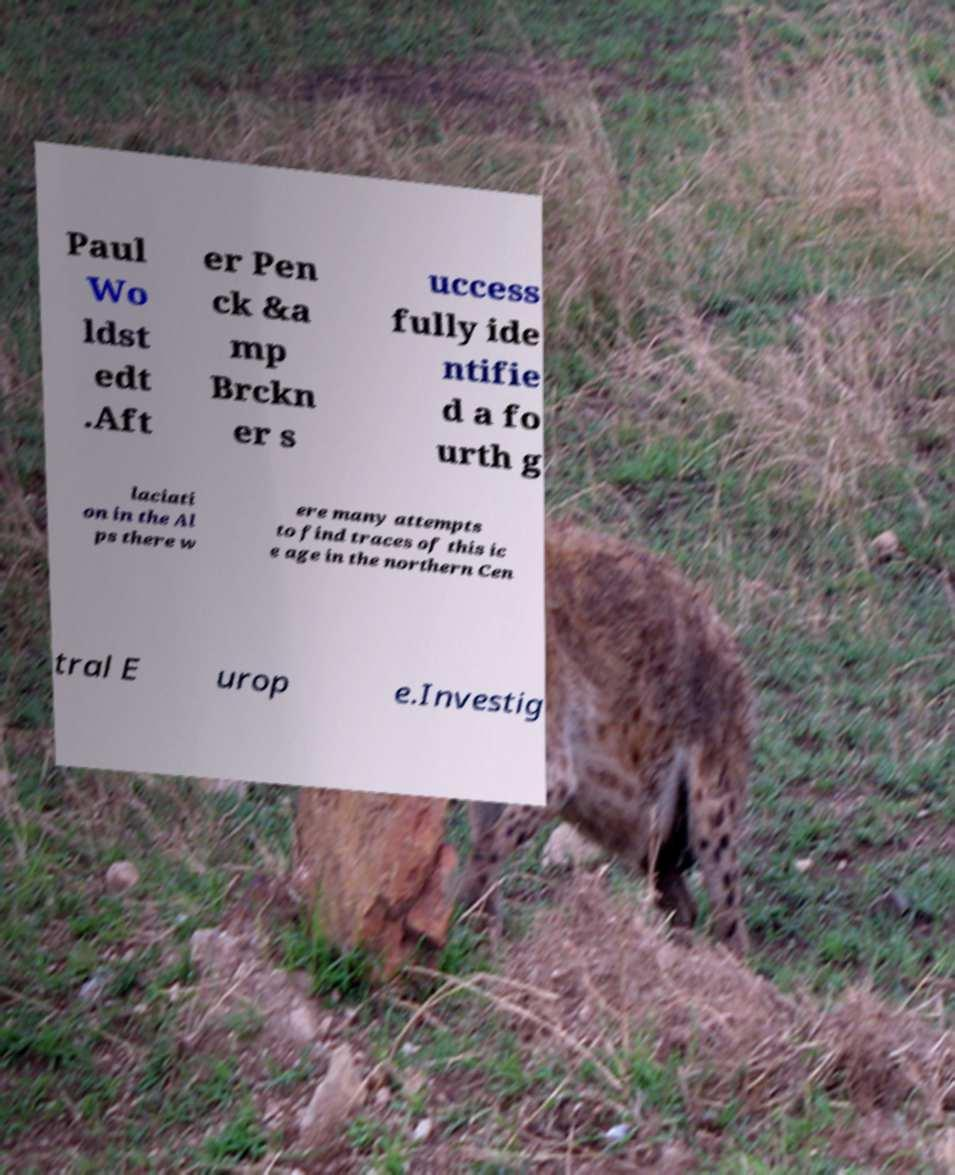Please read and relay the text visible in this image. What does it say? Paul Wo ldst edt .Aft er Pen ck &a mp Brckn er s uccess fully ide ntifie d a fo urth g laciati on in the Al ps there w ere many attempts to find traces of this ic e age in the northern Cen tral E urop e.Investig 